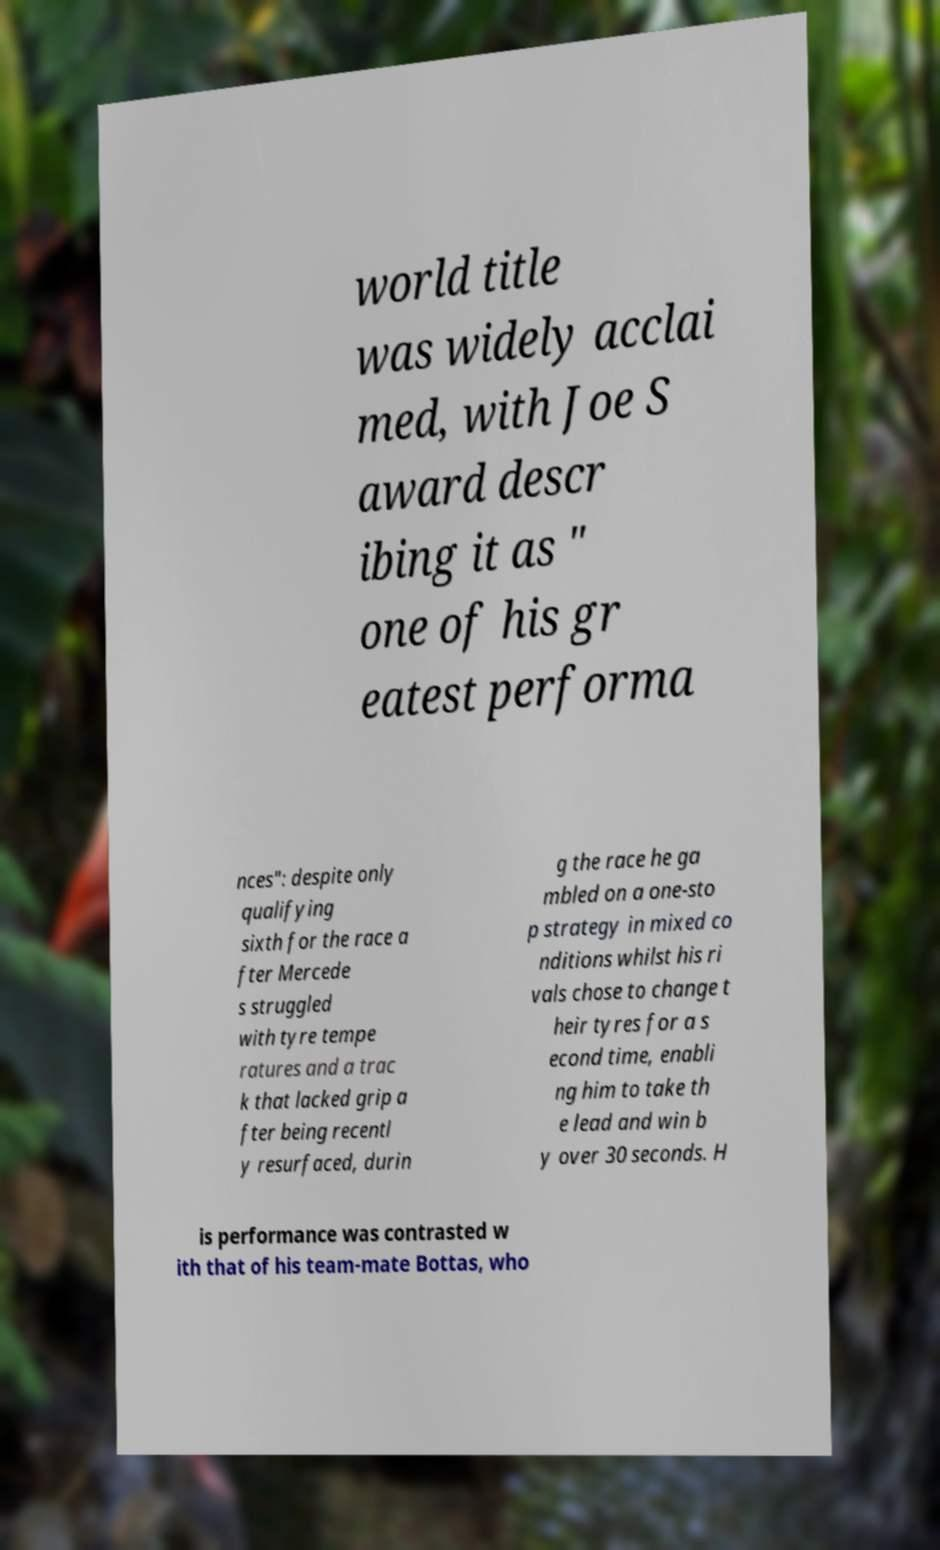Please read and relay the text visible in this image. What does it say? world title was widely acclai med, with Joe S award descr ibing it as " one of his gr eatest performa nces": despite only qualifying sixth for the race a fter Mercede s struggled with tyre tempe ratures and a trac k that lacked grip a fter being recentl y resurfaced, durin g the race he ga mbled on a one-sto p strategy in mixed co nditions whilst his ri vals chose to change t heir tyres for a s econd time, enabli ng him to take th e lead and win b y over 30 seconds. H is performance was contrasted w ith that of his team-mate Bottas, who 